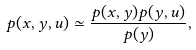Convert formula to latex. <formula><loc_0><loc_0><loc_500><loc_500>p ( x , y , u ) \simeq \frac { p ( x , y ) p ( y , u ) } { p ( y ) } ,</formula> 